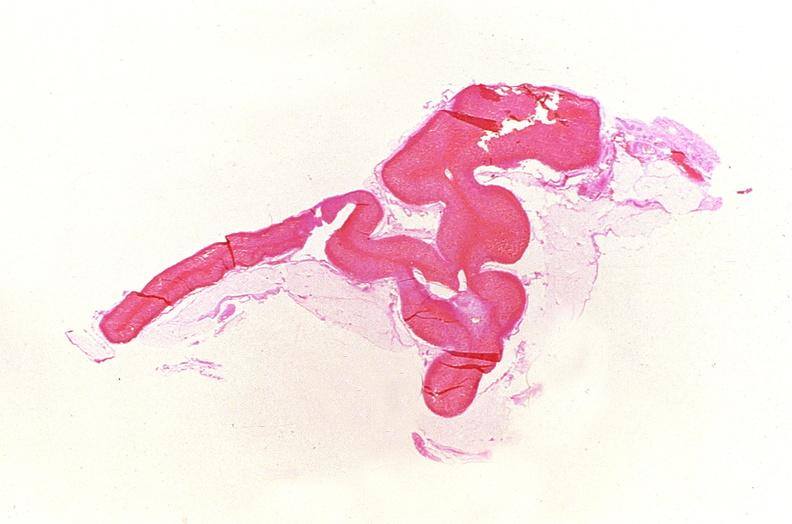does endocrine show adrenal gland, severe hemorrhage waterhouse-friderichsen syndrome?
Answer the question using a single word or phrase. No 